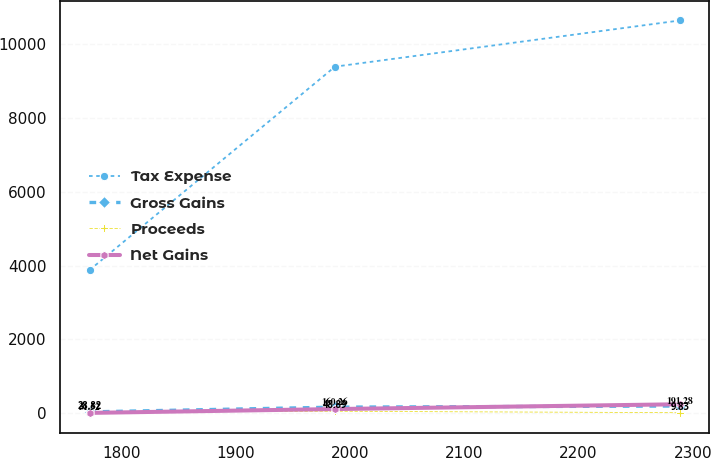<chart> <loc_0><loc_0><loc_500><loc_500><line_chart><ecel><fcel>Tax Expense<fcel>Gross Gains<fcel>Proceeds<fcel>Net Gains<nl><fcel>1772.24<fcel>3878.41<fcel>31.52<fcel>28.82<fcel>4.11<nl><fcel>1986.99<fcel>9397.17<fcel>160.26<fcel>48.89<fcel>108.34<nl><fcel>2288.64<fcel>10649.9<fcel>191.28<fcel>9.83<fcel>238.69<nl></chart> 